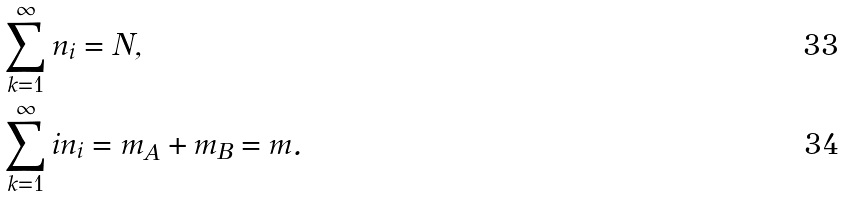Convert formula to latex. <formula><loc_0><loc_0><loc_500><loc_500>& \sum _ { k = 1 } ^ { \infty } n _ { i } = N , \\ & \sum _ { k = 1 } ^ { \infty } i n _ { i } = m _ { A } + m _ { B } = m .</formula> 